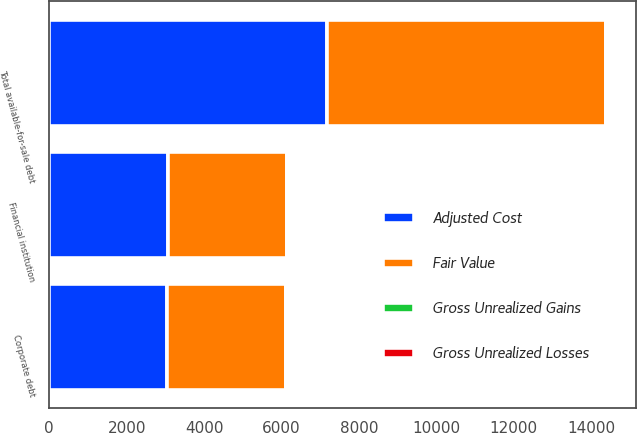Convert chart to OTSL. <chart><loc_0><loc_0><loc_500><loc_500><stacked_bar_chart><ecel><fcel>Corporate debt<fcel>Financial institution<fcel>Total available-for-sale debt<nl><fcel>Fair Value<fcel>3068<fcel>3076<fcel>7213<nl><fcel>Gross Unrealized Gains<fcel>2<fcel>3<fcel>6<nl><fcel>Gross Unrealized Losses<fcel>28<fcel>11<fcel>48<nl><fcel>Adjusted Cost<fcel>3042<fcel>3068<fcel>7171<nl></chart> 